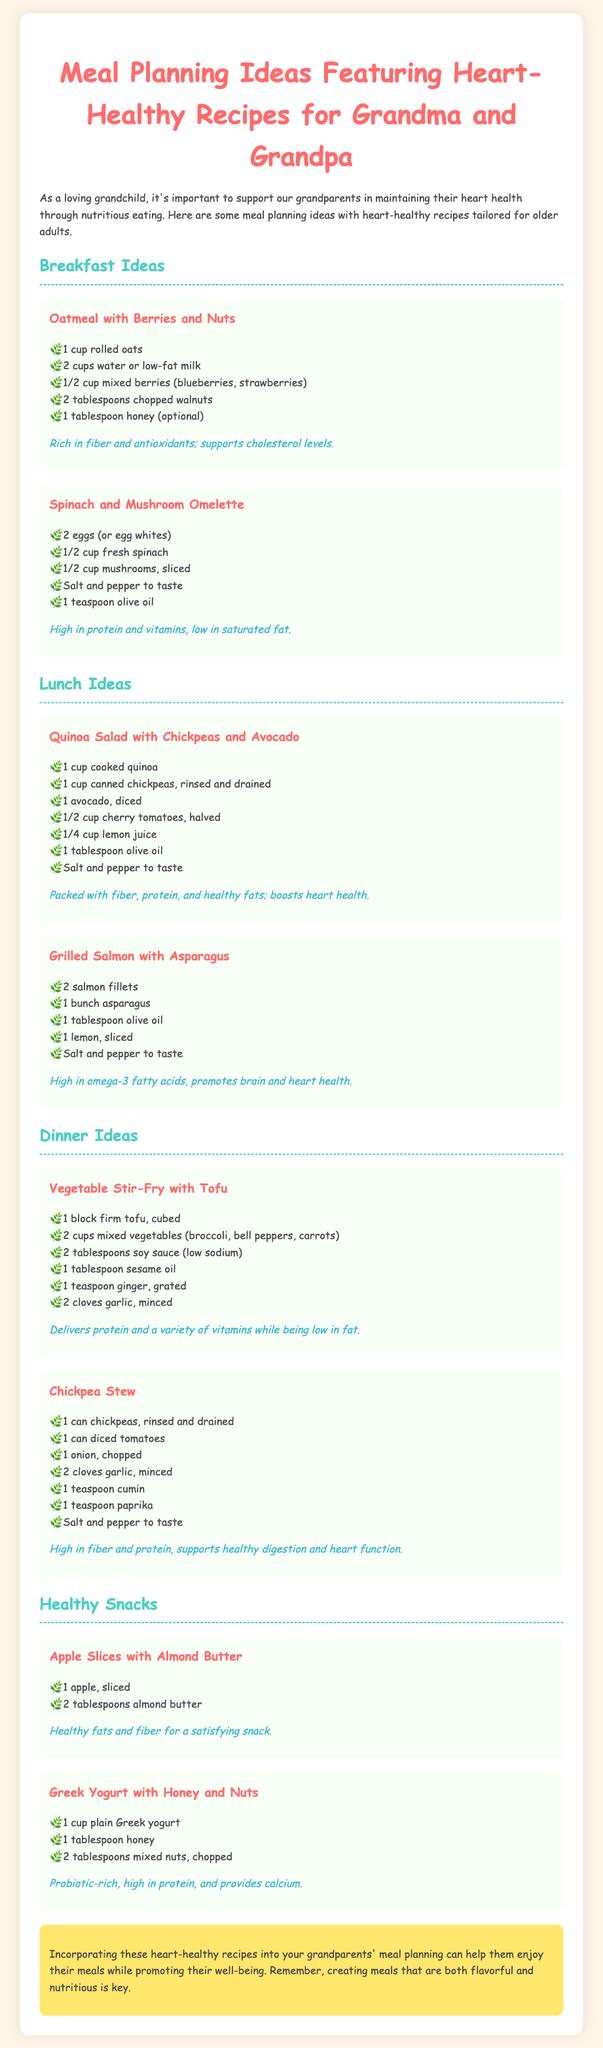What is the title of the document? The title of the document is the main heading displayed at the top, summarizing its purpose.
Answer: Meal Planning Ideas Featuring Heart-Healthy Recipes for Grandma and Grandpa What is a key benefit of oatmeal with berries and nuts? This benefit is specifically mentioned in the meal description, highlighting the health aspects of the recipe.
Answer: Rich in fiber and antioxidants; supports cholesterol levels How many eggs are used in the spinach and mushroom omelette? The number of eggs is listed in the ingredients under the specific meal section to describe the recipe.
Answer: 2 What main ingredient is found in the quinoa salad? This ingredient is essential for the salad and included in the list of items necessary for preparation.
Answer: Chickpeas What cooking oil is recommended for the grilled salmon with asparagus? The type of oil is part of the ingredients for this recipe, illustrating how it enhances the dish.
Answer: Olive oil What is the main protein source in the vegetable stir-fry? The meal description details the main component providing protein in the dish.
Answer: Tofu Which snack includes almond butter? This question points to a specific snack listed in the healthy snack section of the document.
Answer: Apple Slices with Almond Butter How many tablespoons of honey are suggested for Greek yogurt? The amount of honey is mentioned in the yogurt recipe, indicating precise measurement for preparation.
Answer: 1 What essential nutrient does the chickpea stew support? The stew benefits are outlined, emphasizing its contribution to a particular aspect of health.
Answer: Healthy digestion and heart function 